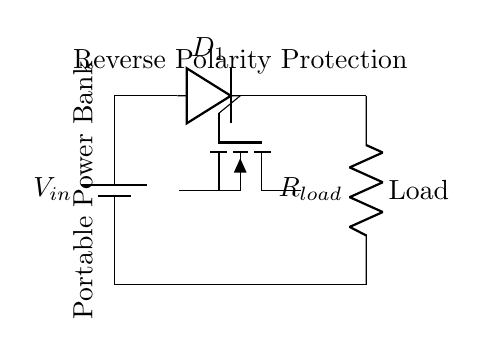What components are present in the circuit? The components visible in the circuit diagram are a battery, a diode, a MOSFET, and a resistor (load). These are the essential parts used for reverse polarity protection in the circuit.
Answer: battery, diode, MOSFET, resistor What is the purpose of the diode in this circuit? The diode is used to prevent current from flowing in the reverse direction, which would occur if the battery is connected with reversed polarity. This protects the other components from damage.
Answer: prevent reverse current What does the MOSFET control in this circuit? The MOSFET acts as a switch that can allow or stop the current flow based on the input voltage, thus playing a crucial role in the reverse polarity protection functionality.
Answer: current flow What would happen if the battery voltage was connected with reverse polarity? If the battery is connected with reverse polarity, the diode will block the current, preventing it from reaching the load and protecting the circuit from damage.
Answer: no current to load What is the function of the resistor labeled as load? The resistor represents the load that the power bank would supply power to, converting electrical energy into other forms of energy, like heat, in a real-world application.
Answer: represent the load How does the circuit ensure that reverse polarity does not damage the load? The design of the circuit includes a diode to block reverse current and a MOSFET that allows proper current flow only when the battery is connected correctly, thus ensuring protection for the load from damages.
Answer: via diode and MOSFET 